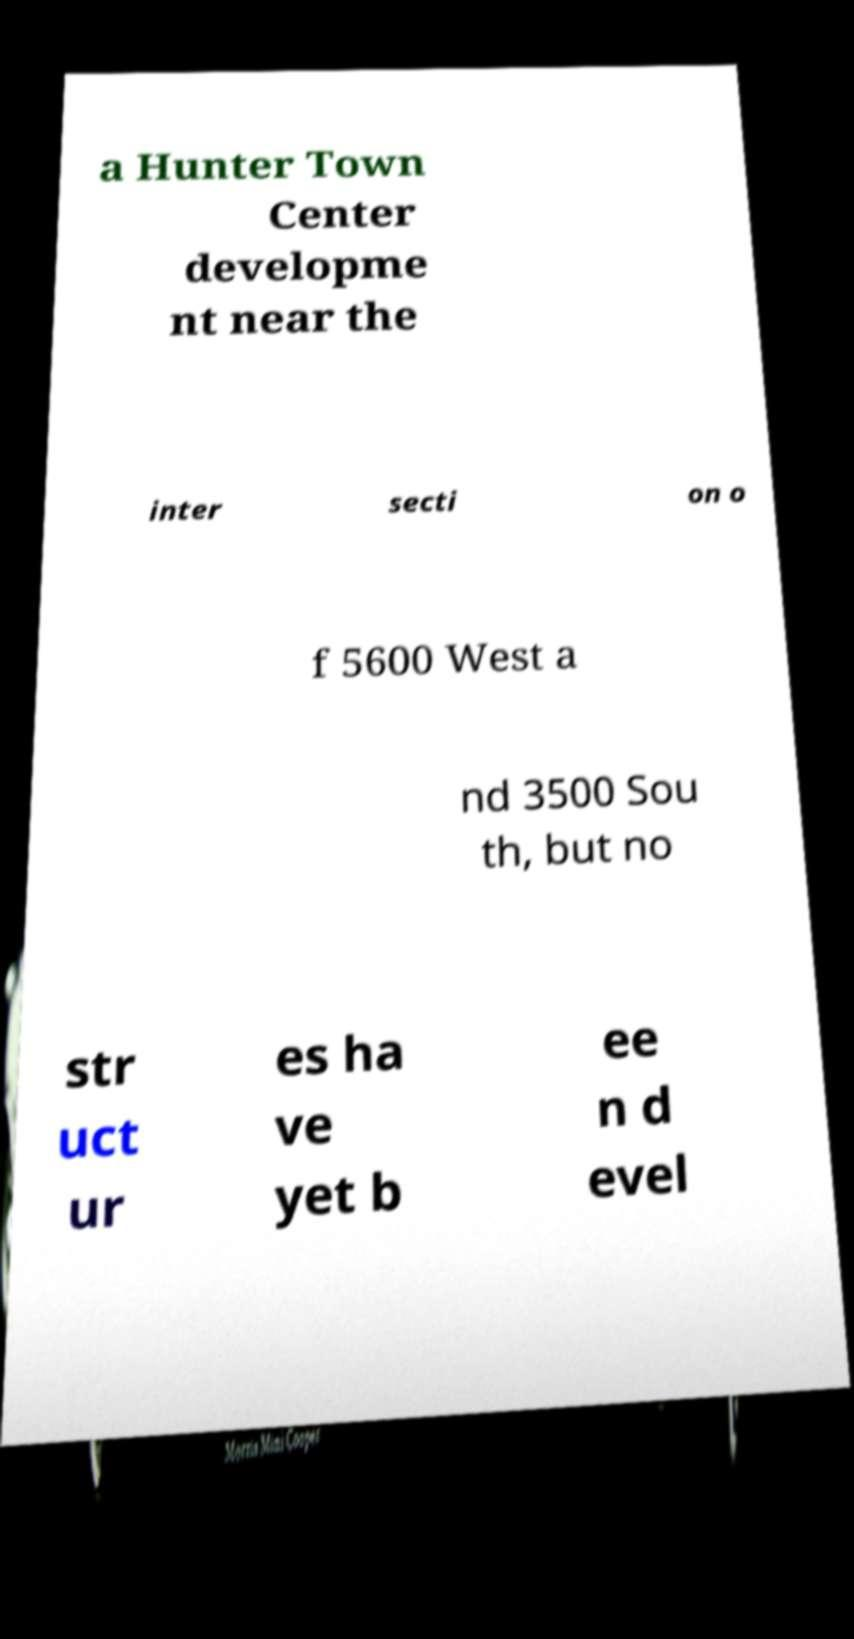Can you read and provide the text displayed in the image?This photo seems to have some interesting text. Can you extract and type it out for me? a Hunter Town Center developme nt near the inter secti on o f 5600 West a nd 3500 Sou th, but no str uct ur es ha ve yet b ee n d evel 